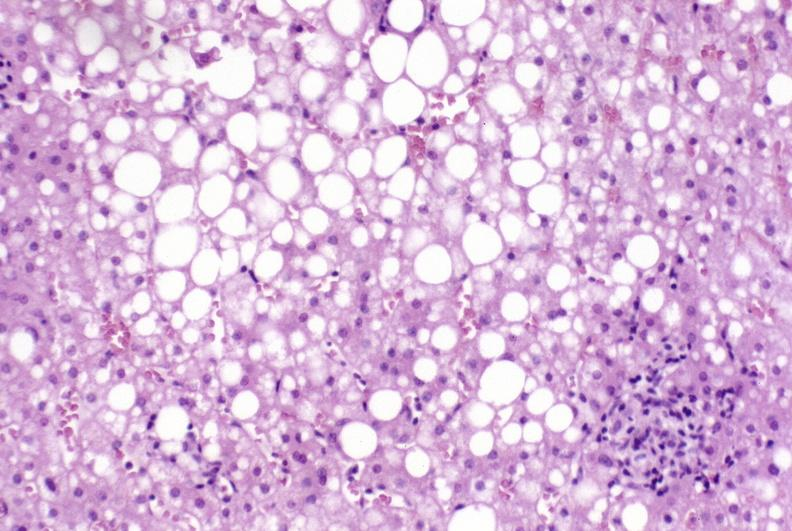what is present?
Answer the question using a single word or phrase. Hepatobiliary 